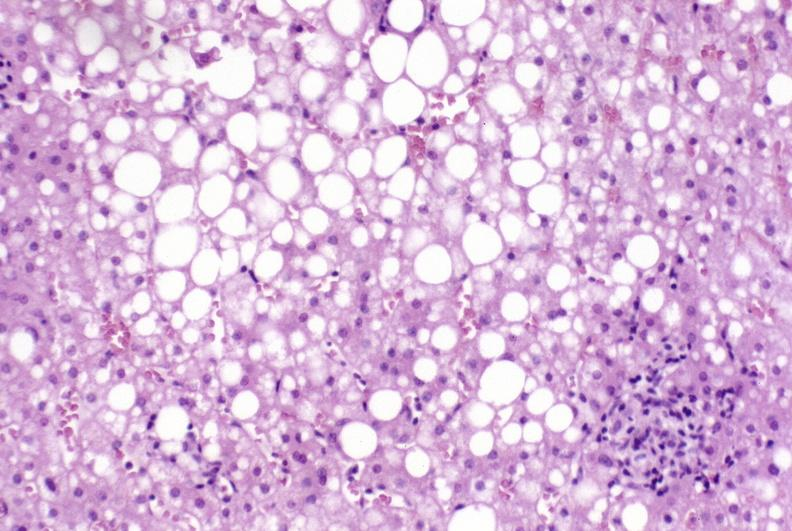what is present?
Answer the question using a single word or phrase. Hepatobiliary 